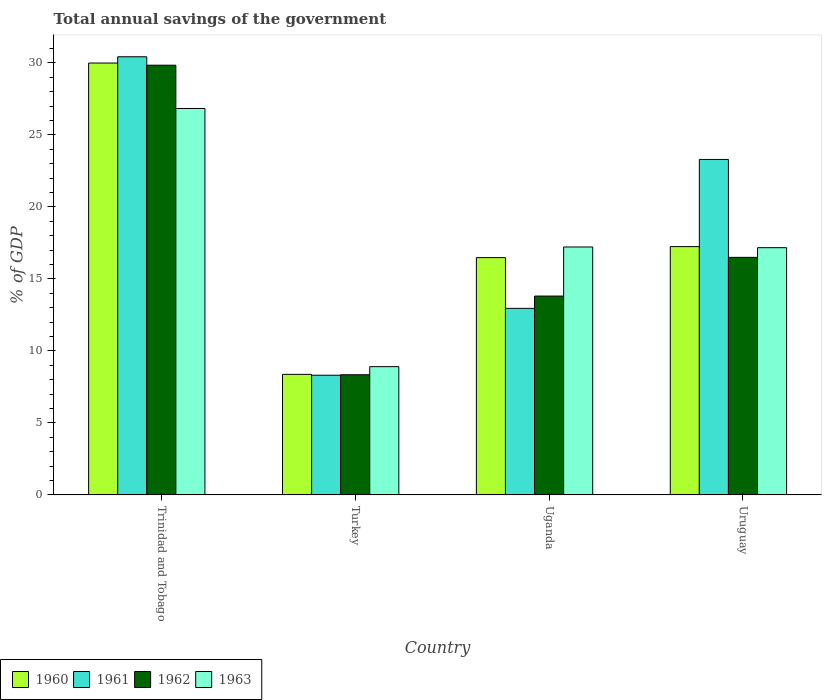How many groups of bars are there?
Keep it short and to the point. 4. Are the number of bars per tick equal to the number of legend labels?
Offer a very short reply. Yes. How many bars are there on the 4th tick from the left?
Provide a succinct answer. 4. How many bars are there on the 4th tick from the right?
Offer a very short reply. 4. What is the label of the 1st group of bars from the left?
Keep it short and to the point. Trinidad and Tobago. In how many cases, is the number of bars for a given country not equal to the number of legend labels?
Provide a short and direct response. 0. What is the total annual savings of the government in 1960 in Uruguay?
Your answer should be very brief. 17.24. Across all countries, what is the maximum total annual savings of the government in 1962?
Your answer should be compact. 29.84. Across all countries, what is the minimum total annual savings of the government in 1960?
Your answer should be compact. 8.37. In which country was the total annual savings of the government in 1961 maximum?
Give a very brief answer. Trinidad and Tobago. What is the total total annual savings of the government in 1961 in the graph?
Give a very brief answer. 74.99. What is the difference between the total annual savings of the government in 1962 in Uganda and that in Uruguay?
Your answer should be very brief. -2.69. What is the difference between the total annual savings of the government in 1961 in Trinidad and Tobago and the total annual savings of the government in 1960 in Uganda?
Provide a short and direct response. 13.95. What is the average total annual savings of the government in 1962 per country?
Your answer should be very brief. 17.12. What is the difference between the total annual savings of the government of/in 1961 and total annual savings of the government of/in 1962 in Uruguay?
Offer a very short reply. 6.8. In how many countries, is the total annual savings of the government in 1961 greater than 28 %?
Offer a terse response. 1. What is the ratio of the total annual savings of the government in 1962 in Trinidad and Tobago to that in Uganda?
Ensure brevity in your answer.  2.16. Is the total annual savings of the government in 1963 in Turkey less than that in Uganda?
Your answer should be compact. Yes. Is the difference between the total annual savings of the government in 1961 in Trinidad and Tobago and Uganda greater than the difference between the total annual savings of the government in 1962 in Trinidad and Tobago and Uganda?
Provide a short and direct response. Yes. What is the difference between the highest and the second highest total annual savings of the government in 1963?
Provide a succinct answer. -9.62. What is the difference between the highest and the lowest total annual savings of the government in 1960?
Keep it short and to the point. 21.62. Is it the case that in every country, the sum of the total annual savings of the government in 1960 and total annual savings of the government in 1962 is greater than the sum of total annual savings of the government in 1961 and total annual savings of the government in 1963?
Ensure brevity in your answer.  No. Are all the bars in the graph horizontal?
Your answer should be compact. No. How many countries are there in the graph?
Offer a very short reply. 4. What is the difference between two consecutive major ticks on the Y-axis?
Your answer should be very brief. 5. Where does the legend appear in the graph?
Your answer should be compact. Bottom left. How many legend labels are there?
Provide a succinct answer. 4. How are the legend labels stacked?
Your response must be concise. Horizontal. What is the title of the graph?
Provide a short and direct response. Total annual savings of the government. What is the label or title of the Y-axis?
Your response must be concise. % of GDP. What is the % of GDP of 1960 in Trinidad and Tobago?
Make the answer very short. 29.99. What is the % of GDP of 1961 in Trinidad and Tobago?
Your answer should be compact. 30.42. What is the % of GDP in 1962 in Trinidad and Tobago?
Provide a short and direct response. 29.84. What is the % of GDP of 1963 in Trinidad and Tobago?
Provide a succinct answer. 26.83. What is the % of GDP of 1960 in Turkey?
Keep it short and to the point. 8.37. What is the % of GDP in 1961 in Turkey?
Offer a very short reply. 8.31. What is the % of GDP in 1962 in Turkey?
Give a very brief answer. 8.34. What is the % of GDP in 1963 in Turkey?
Provide a short and direct response. 8.91. What is the % of GDP in 1960 in Uganda?
Give a very brief answer. 16.48. What is the % of GDP in 1961 in Uganda?
Offer a terse response. 12.95. What is the % of GDP of 1962 in Uganda?
Provide a short and direct response. 13.81. What is the % of GDP of 1963 in Uganda?
Make the answer very short. 17.22. What is the % of GDP of 1960 in Uruguay?
Provide a short and direct response. 17.24. What is the % of GDP in 1961 in Uruguay?
Ensure brevity in your answer.  23.3. What is the % of GDP in 1962 in Uruguay?
Provide a short and direct response. 16.49. What is the % of GDP of 1963 in Uruguay?
Give a very brief answer. 17.17. Across all countries, what is the maximum % of GDP in 1960?
Make the answer very short. 29.99. Across all countries, what is the maximum % of GDP of 1961?
Provide a succinct answer. 30.42. Across all countries, what is the maximum % of GDP in 1962?
Your response must be concise. 29.84. Across all countries, what is the maximum % of GDP in 1963?
Your response must be concise. 26.83. Across all countries, what is the minimum % of GDP in 1960?
Make the answer very short. 8.37. Across all countries, what is the minimum % of GDP in 1961?
Keep it short and to the point. 8.31. Across all countries, what is the minimum % of GDP in 1962?
Keep it short and to the point. 8.34. Across all countries, what is the minimum % of GDP in 1963?
Give a very brief answer. 8.91. What is the total % of GDP of 1960 in the graph?
Offer a terse response. 72.08. What is the total % of GDP in 1961 in the graph?
Your response must be concise. 74.99. What is the total % of GDP of 1962 in the graph?
Your response must be concise. 68.49. What is the total % of GDP of 1963 in the graph?
Make the answer very short. 70.12. What is the difference between the % of GDP of 1960 in Trinidad and Tobago and that in Turkey?
Provide a succinct answer. 21.62. What is the difference between the % of GDP in 1961 in Trinidad and Tobago and that in Turkey?
Ensure brevity in your answer.  22.11. What is the difference between the % of GDP in 1962 in Trinidad and Tobago and that in Turkey?
Make the answer very short. 21.5. What is the difference between the % of GDP in 1963 in Trinidad and Tobago and that in Turkey?
Offer a very short reply. 17.93. What is the difference between the % of GDP in 1960 in Trinidad and Tobago and that in Uganda?
Keep it short and to the point. 13.51. What is the difference between the % of GDP of 1961 in Trinidad and Tobago and that in Uganda?
Your answer should be very brief. 17.47. What is the difference between the % of GDP of 1962 in Trinidad and Tobago and that in Uganda?
Provide a short and direct response. 16.03. What is the difference between the % of GDP in 1963 in Trinidad and Tobago and that in Uganda?
Offer a very short reply. 9.62. What is the difference between the % of GDP of 1960 in Trinidad and Tobago and that in Uruguay?
Provide a succinct answer. 12.75. What is the difference between the % of GDP of 1961 in Trinidad and Tobago and that in Uruguay?
Make the answer very short. 7.13. What is the difference between the % of GDP of 1962 in Trinidad and Tobago and that in Uruguay?
Your response must be concise. 13.34. What is the difference between the % of GDP in 1963 in Trinidad and Tobago and that in Uruguay?
Keep it short and to the point. 9.67. What is the difference between the % of GDP of 1960 in Turkey and that in Uganda?
Provide a succinct answer. -8.11. What is the difference between the % of GDP of 1961 in Turkey and that in Uganda?
Offer a very short reply. -4.64. What is the difference between the % of GDP in 1962 in Turkey and that in Uganda?
Offer a terse response. -5.46. What is the difference between the % of GDP in 1963 in Turkey and that in Uganda?
Ensure brevity in your answer.  -8.31. What is the difference between the % of GDP of 1960 in Turkey and that in Uruguay?
Provide a short and direct response. -8.87. What is the difference between the % of GDP in 1961 in Turkey and that in Uruguay?
Ensure brevity in your answer.  -14.99. What is the difference between the % of GDP in 1962 in Turkey and that in Uruguay?
Ensure brevity in your answer.  -8.15. What is the difference between the % of GDP in 1963 in Turkey and that in Uruguay?
Provide a short and direct response. -8.26. What is the difference between the % of GDP in 1960 in Uganda and that in Uruguay?
Offer a very short reply. -0.76. What is the difference between the % of GDP of 1961 in Uganda and that in Uruguay?
Provide a short and direct response. -10.34. What is the difference between the % of GDP of 1962 in Uganda and that in Uruguay?
Provide a succinct answer. -2.69. What is the difference between the % of GDP in 1963 in Uganda and that in Uruguay?
Provide a succinct answer. 0.05. What is the difference between the % of GDP of 1960 in Trinidad and Tobago and the % of GDP of 1961 in Turkey?
Provide a succinct answer. 21.68. What is the difference between the % of GDP in 1960 in Trinidad and Tobago and the % of GDP in 1962 in Turkey?
Your answer should be very brief. 21.65. What is the difference between the % of GDP of 1960 in Trinidad and Tobago and the % of GDP of 1963 in Turkey?
Give a very brief answer. 21.08. What is the difference between the % of GDP in 1961 in Trinidad and Tobago and the % of GDP in 1962 in Turkey?
Your response must be concise. 22.08. What is the difference between the % of GDP in 1961 in Trinidad and Tobago and the % of GDP in 1963 in Turkey?
Make the answer very short. 21.52. What is the difference between the % of GDP in 1962 in Trinidad and Tobago and the % of GDP in 1963 in Turkey?
Make the answer very short. 20.93. What is the difference between the % of GDP in 1960 in Trinidad and Tobago and the % of GDP in 1961 in Uganda?
Offer a very short reply. 17.04. What is the difference between the % of GDP of 1960 in Trinidad and Tobago and the % of GDP of 1962 in Uganda?
Keep it short and to the point. 16.18. What is the difference between the % of GDP of 1960 in Trinidad and Tobago and the % of GDP of 1963 in Uganda?
Make the answer very short. 12.77. What is the difference between the % of GDP of 1961 in Trinidad and Tobago and the % of GDP of 1962 in Uganda?
Your answer should be very brief. 16.62. What is the difference between the % of GDP in 1961 in Trinidad and Tobago and the % of GDP in 1963 in Uganda?
Your answer should be compact. 13.21. What is the difference between the % of GDP in 1962 in Trinidad and Tobago and the % of GDP in 1963 in Uganda?
Your answer should be compact. 12.62. What is the difference between the % of GDP in 1960 in Trinidad and Tobago and the % of GDP in 1961 in Uruguay?
Provide a short and direct response. 6.69. What is the difference between the % of GDP in 1960 in Trinidad and Tobago and the % of GDP in 1962 in Uruguay?
Make the answer very short. 13.5. What is the difference between the % of GDP in 1960 in Trinidad and Tobago and the % of GDP in 1963 in Uruguay?
Keep it short and to the point. 12.82. What is the difference between the % of GDP in 1961 in Trinidad and Tobago and the % of GDP in 1962 in Uruguay?
Provide a short and direct response. 13.93. What is the difference between the % of GDP of 1961 in Trinidad and Tobago and the % of GDP of 1963 in Uruguay?
Offer a terse response. 13.26. What is the difference between the % of GDP of 1962 in Trinidad and Tobago and the % of GDP of 1963 in Uruguay?
Your response must be concise. 12.67. What is the difference between the % of GDP in 1960 in Turkey and the % of GDP in 1961 in Uganda?
Offer a very short reply. -4.58. What is the difference between the % of GDP in 1960 in Turkey and the % of GDP in 1962 in Uganda?
Offer a very short reply. -5.44. What is the difference between the % of GDP in 1960 in Turkey and the % of GDP in 1963 in Uganda?
Give a very brief answer. -8.85. What is the difference between the % of GDP in 1961 in Turkey and the % of GDP in 1962 in Uganda?
Give a very brief answer. -5.5. What is the difference between the % of GDP in 1961 in Turkey and the % of GDP in 1963 in Uganda?
Provide a succinct answer. -8.91. What is the difference between the % of GDP in 1962 in Turkey and the % of GDP in 1963 in Uganda?
Your response must be concise. -8.87. What is the difference between the % of GDP of 1960 in Turkey and the % of GDP of 1961 in Uruguay?
Offer a very short reply. -14.93. What is the difference between the % of GDP in 1960 in Turkey and the % of GDP in 1962 in Uruguay?
Your answer should be very brief. -8.12. What is the difference between the % of GDP in 1960 in Turkey and the % of GDP in 1963 in Uruguay?
Your answer should be compact. -8.8. What is the difference between the % of GDP in 1961 in Turkey and the % of GDP in 1962 in Uruguay?
Ensure brevity in your answer.  -8.18. What is the difference between the % of GDP of 1961 in Turkey and the % of GDP of 1963 in Uruguay?
Provide a succinct answer. -8.86. What is the difference between the % of GDP of 1962 in Turkey and the % of GDP of 1963 in Uruguay?
Provide a short and direct response. -8.82. What is the difference between the % of GDP in 1960 in Uganda and the % of GDP in 1961 in Uruguay?
Your answer should be compact. -6.82. What is the difference between the % of GDP in 1960 in Uganda and the % of GDP in 1962 in Uruguay?
Make the answer very short. -0.02. What is the difference between the % of GDP in 1960 in Uganda and the % of GDP in 1963 in Uruguay?
Ensure brevity in your answer.  -0.69. What is the difference between the % of GDP of 1961 in Uganda and the % of GDP of 1962 in Uruguay?
Your response must be concise. -3.54. What is the difference between the % of GDP in 1961 in Uganda and the % of GDP in 1963 in Uruguay?
Your answer should be compact. -4.21. What is the difference between the % of GDP in 1962 in Uganda and the % of GDP in 1963 in Uruguay?
Your answer should be compact. -3.36. What is the average % of GDP in 1960 per country?
Give a very brief answer. 18.02. What is the average % of GDP in 1961 per country?
Keep it short and to the point. 18.75. What is the average % of GDP of 1962 per country?
Provide a succinct answer. 17.12. What is the average % of GDP of 1963 per country?
Offer a very short reply. 17.53. What is the difference between the % of GDP in 1960 and % of GDP in 1961 in Trinidad and Tobago?
Offer a very short reply. -0.43. What is the difference between the % of GDP in 1960 and % of GDP in 1962 in Trinidad and Tobago?
Provide a succinct answer. 0.15. What is the difference between the % of GDP of 1960 and % of GDP of 1963 in Trinidad and Tobago?
Offer a terse response. 3.16. What is the difference between the % of GDP in 1961 and % of GDP in 1962 in Trinidad and Tobago?
Ensure brevity in your answer.  0.59. What is the difference between the % of GDP in 1961 and % of GDP in 1963 in Trinidad and Tobago?
Provide a succinct answer. 3.59. What is the difference between the % of GDP in 1962 and % of GDP in 1963 in Trinidad and Tobago?
Your response must be concise. 3. What is the difference between the % of GDP of 1960 and % of GDP of 1961 in Turkey?
Ensure brevity in your answer.  0.06. What is the difference between the % of GDP in 1960 and % of GDP in 1962 in Turkey?
Provide a succinct answer. 0.03. What is the difference between the % of GDP in 1960 and % of GDP in 1963 in Turkey?
Keep it short and to the point. -0.54. What is the difference between the % of GDP of 1961 and % of GDP of 1962 in Turkey?
Give a very brief answer. -0.03. What is the difference between the % of GDP in 1961 and % of GDP in 1963 in Turkey?
Make the answer very short. -0.6. What is the difference between the % of GDP of 1962 and % of GDP of 1963 in Turkey?
Your answer should be very brief. -0.56. What is the difference between the % of GDP in 1960 and % of GDP in 1961 in Uganda?
Your answer should be very brief. 3.52. What is the difference between the % of GDP in 1960 and % of GDP in 1962 in Uganda?
Your response must be concise. 2.67. What is the difference between the % of GDP in 1960 and % of GDP in 1963 in Uganda?
Make the answer very short. -0.74. What is the difference between the % of GDP in 1961 and % of GDP in 1962 in Uganda?
Keep it short and to the point. -0.85. What is the difference between the % of GDP in 1961 and % of GDP in 1963 in Uganda?
Your response must be concise. -4.26. What is the difference between the % of GDP of 1962 and % of GDP of 1963 in Uganda?
Ensure brevity in your answer.  -3.41. What is the difference between the % of GDP of 1960 and % of GDP of 1961 in Uruguay?
Your answer should be very brief. -6.05. What is the difference between the % of GDP of 1960 and % of GDP of 1962 in Uruguay?
Give a very brief answer. 0.75. What is the difference between the % of GDP in 1960 and % of GDP in 1963 in Uruguay?
Your answer should be compact. 0.07. What is the difference between the % of GDP of 1961 and % of GDP of 1962 in Uruguay?
Make the answer very short. 6.8. What is the difference between the % of GDP of 1961 and % of GDP of 1963 in Uruguay?
Your response must be concise. 6.13. What is the difference between the % of GDP of 1962 and % of GDP of 1963 in Uruguay?
Your response must be concise. -0.67. What is the ratio of the % of GDP of 1960 in Trinidad and Tobago to that in Turkey?
Offer a very short reply. 3.58. What is the ratio of the % of GDP in 1961 in Trinidad and Tobago to that in Turkey?
Your response must be concise. 3.66. What is the ratio of the % of GDP of 1962 in Trinidad and Tobago to that in Turkey?
Your answer should be very brief. 3.58. What is the ratio of the % of GDP of 1963 in Trinidad and Tobago to that in Turkey?
Make the answer very short. 3.01. What is the ratio of the % of GDP in 1960 in Trinidad and Tobago to that in Uganda?
Offer a terse response. 1.82. What is the ratio of the % of GDP of 1961 in Trinidad and Tobago to that in Uganda?
Your response must be concise. 2.35. What is the ratio of the % of GDP of 1962 in Trinidad and Tobago to that in Uganda?
Your response must be concise. 2.16. What is the ratio of the % of GDP in 1963 in Trinidad and Tobago to that in Uganda?
Give a very brief answer. 1.56. What is the ratio of the % of GDP in 1960 in Trinidad and Tobago to that in Uruguay?
Offer a very short reply. 1.74. What is the ratio of the % of GDP of 1961 in Trinidad and Tobago to that in Uruguay?
Provide a succinct answer. 1.31. What is the ratio of the % of GDP of 1962 in Trinidad and Tobago to that in Uruguay?
Keep it short and to the point. 1.81. What is the ratio of the % of GDP of 1963 in Trinidad and Tobago to that in Uruguay?
Ensure brevity in your answer.  1.56. What is the ratio of the % of GDP in 1960 in Turkey to that in Uganda?
Your answer should be compact. 0.51. What is the ratio of the % of GDP of 1961 in Turkey to that in Uganda?
Ensure brevity in your answer.  0.64. What is the ratio of the % of GDP of 1962 in Turkey to that in Uganda?
Offer a terse response. 0.6. What is the ratio of the % of GDP of 1963 in Turkey to that in Uganda?
Your response must be concise. 0.52. What is the ratio of the % of GDP of 1960 in Turkey to that in Uruguay?
Provide a short and direct response. 0.49. What is the ratio of the % of GDP of 1961 in Turkey to that in Uruguay?
Make the answer very short. 0.36. What is the ratio of the % of GDP in 1962 in Turkey to that in Uruguay?
Make the answer very short. 0.51. What is the ratio of the % of GDP in 1963 in Turkey to that in Uruguay?
Your answer should be compact. 0.52. What is the ratio of the % of GDP in 1960 in Uganda to that in Uruguay?
Your response must be concise. 0.96. What is the ratio of the % of GDP of 1961 in Uganda to that in Uruguay?
Keep it short and to the point. 0.56. What is the ratio of the % of GDP in 1962 in Uganda to that in Uruguay?
Provide a succinct answer. 0.84. What is the difference between the highest and the second highest % of GDP in 1960?
Your answer should be very brief. 12.75. What is the difference between the highest and the second highest % of GDP in 1961?
Make the answer very short. 7.13. What is the difference between the highest and the second highest % of GDP in 1962?
Offer a terse response. 13.34. What is the difference between the highest and the second highest % of GDP in 1963?
Your response must be concise. 9.62. What is the difference between the highest and the lowest % of GDP of 1960?
Your response must be concise. 21.62. What is the difference between the highest and the lowest % of GDP in 1961?
Your response must be concise. 22.11. What is the difference between the highest and the lowest % of GDP in 1962?
Offer a terse response. 21.5. What is the difference between the highest and the lowest % of GDP in 1963?
Offer a terse response. 17.93. 